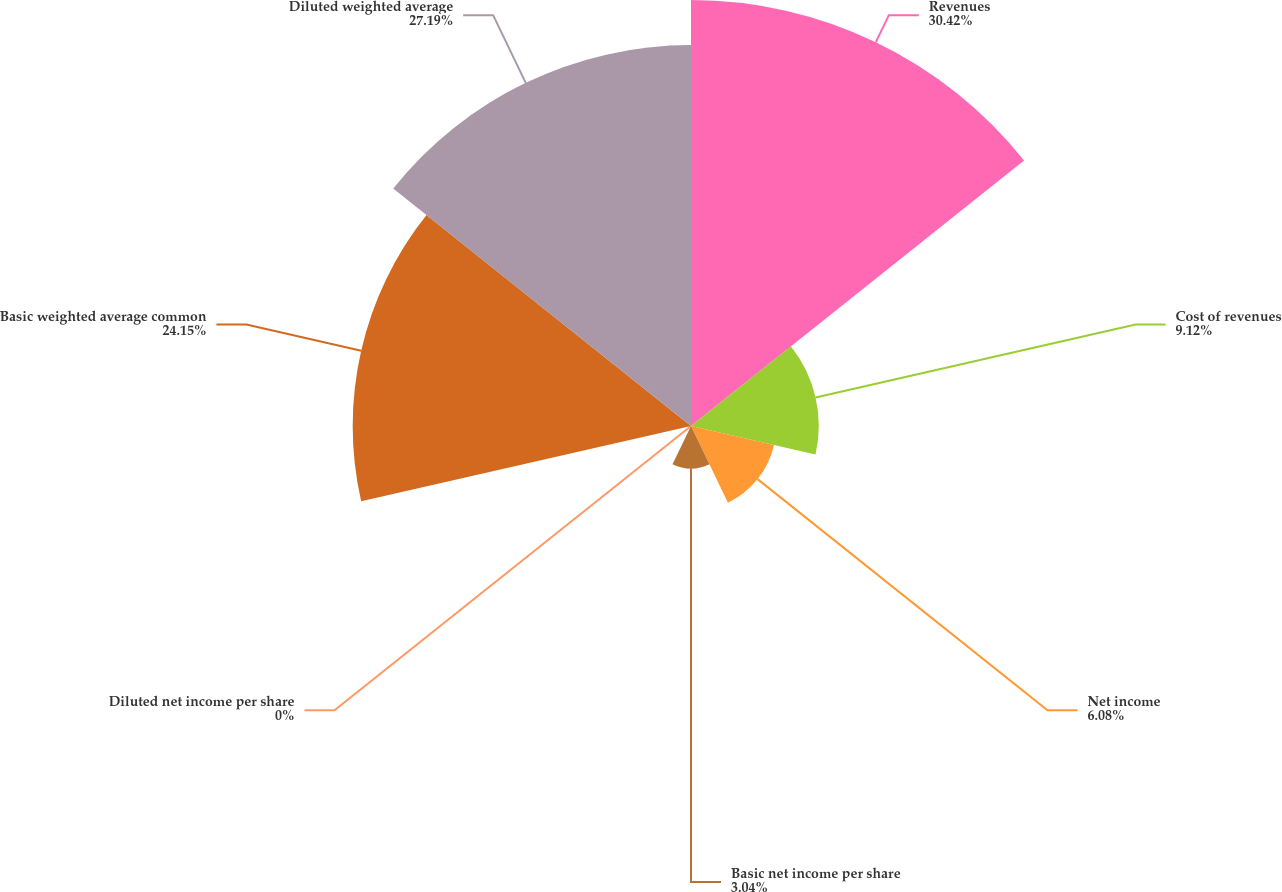<chart> <loc_0><loc_0><loc_500><loc_500><pie_chart><fcel>Revenues<fcel>Cost of revenues<fcel>Net income<fcel>Basic net income per share<fcel>Diluted net income per share<fcel>Basic weighted average common<fcel>Diluted weighted average<nl><fcel>30.41%<fcel>9.12%<fcel>6.08%<fcel>3.04%<fcel>0.0%<fcel>24.15%<fcel>27.19%<nl></chart> 